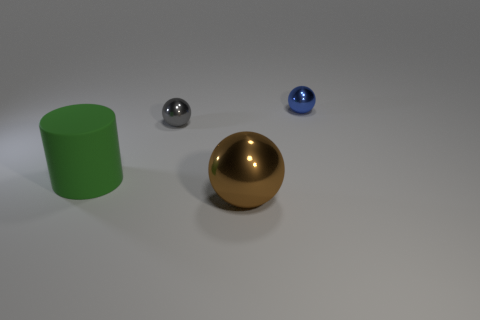What might be the purpose of the arrangement of these objects? This arrangement of objects, with their varying materials and colors, could be a setup designed to demonstrate or study the reflections and lighting on different surfaces. 